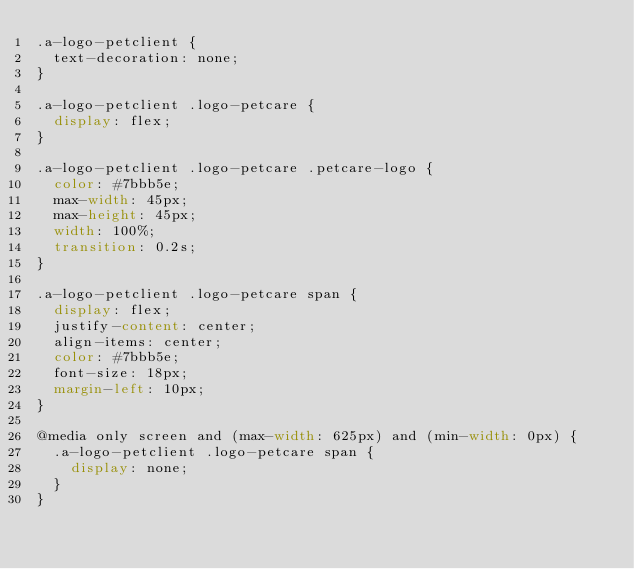Convert code to text. <code><loc_0><loc_0><loc_500><loc_500><_CSS_>.a-logo-petclient {
  text-decoration: none;
}

.a-logo-petclient .logo-petcare {
  display: flex;
}

.a-logo-petclient .logo-petcare .petcare-logo {
  color: #7bbb5e;
  max-width: 45px;
  max-height: 45px;
  width: 100%;
  transition: 0.2s;
}

.a-logo-petclient .logo-petcare span {
  display: flex;
  justify-content: center;
  align-items: center;
  color: #7bbb5e;
  font-size: 18px;
  margin-left: 10px;
}

@media only screen and (max-width: 625px) and (min-width: 0px) {
  .a-logo-petclient .logo-petcare span {
    display: none;
  }
}</code> 